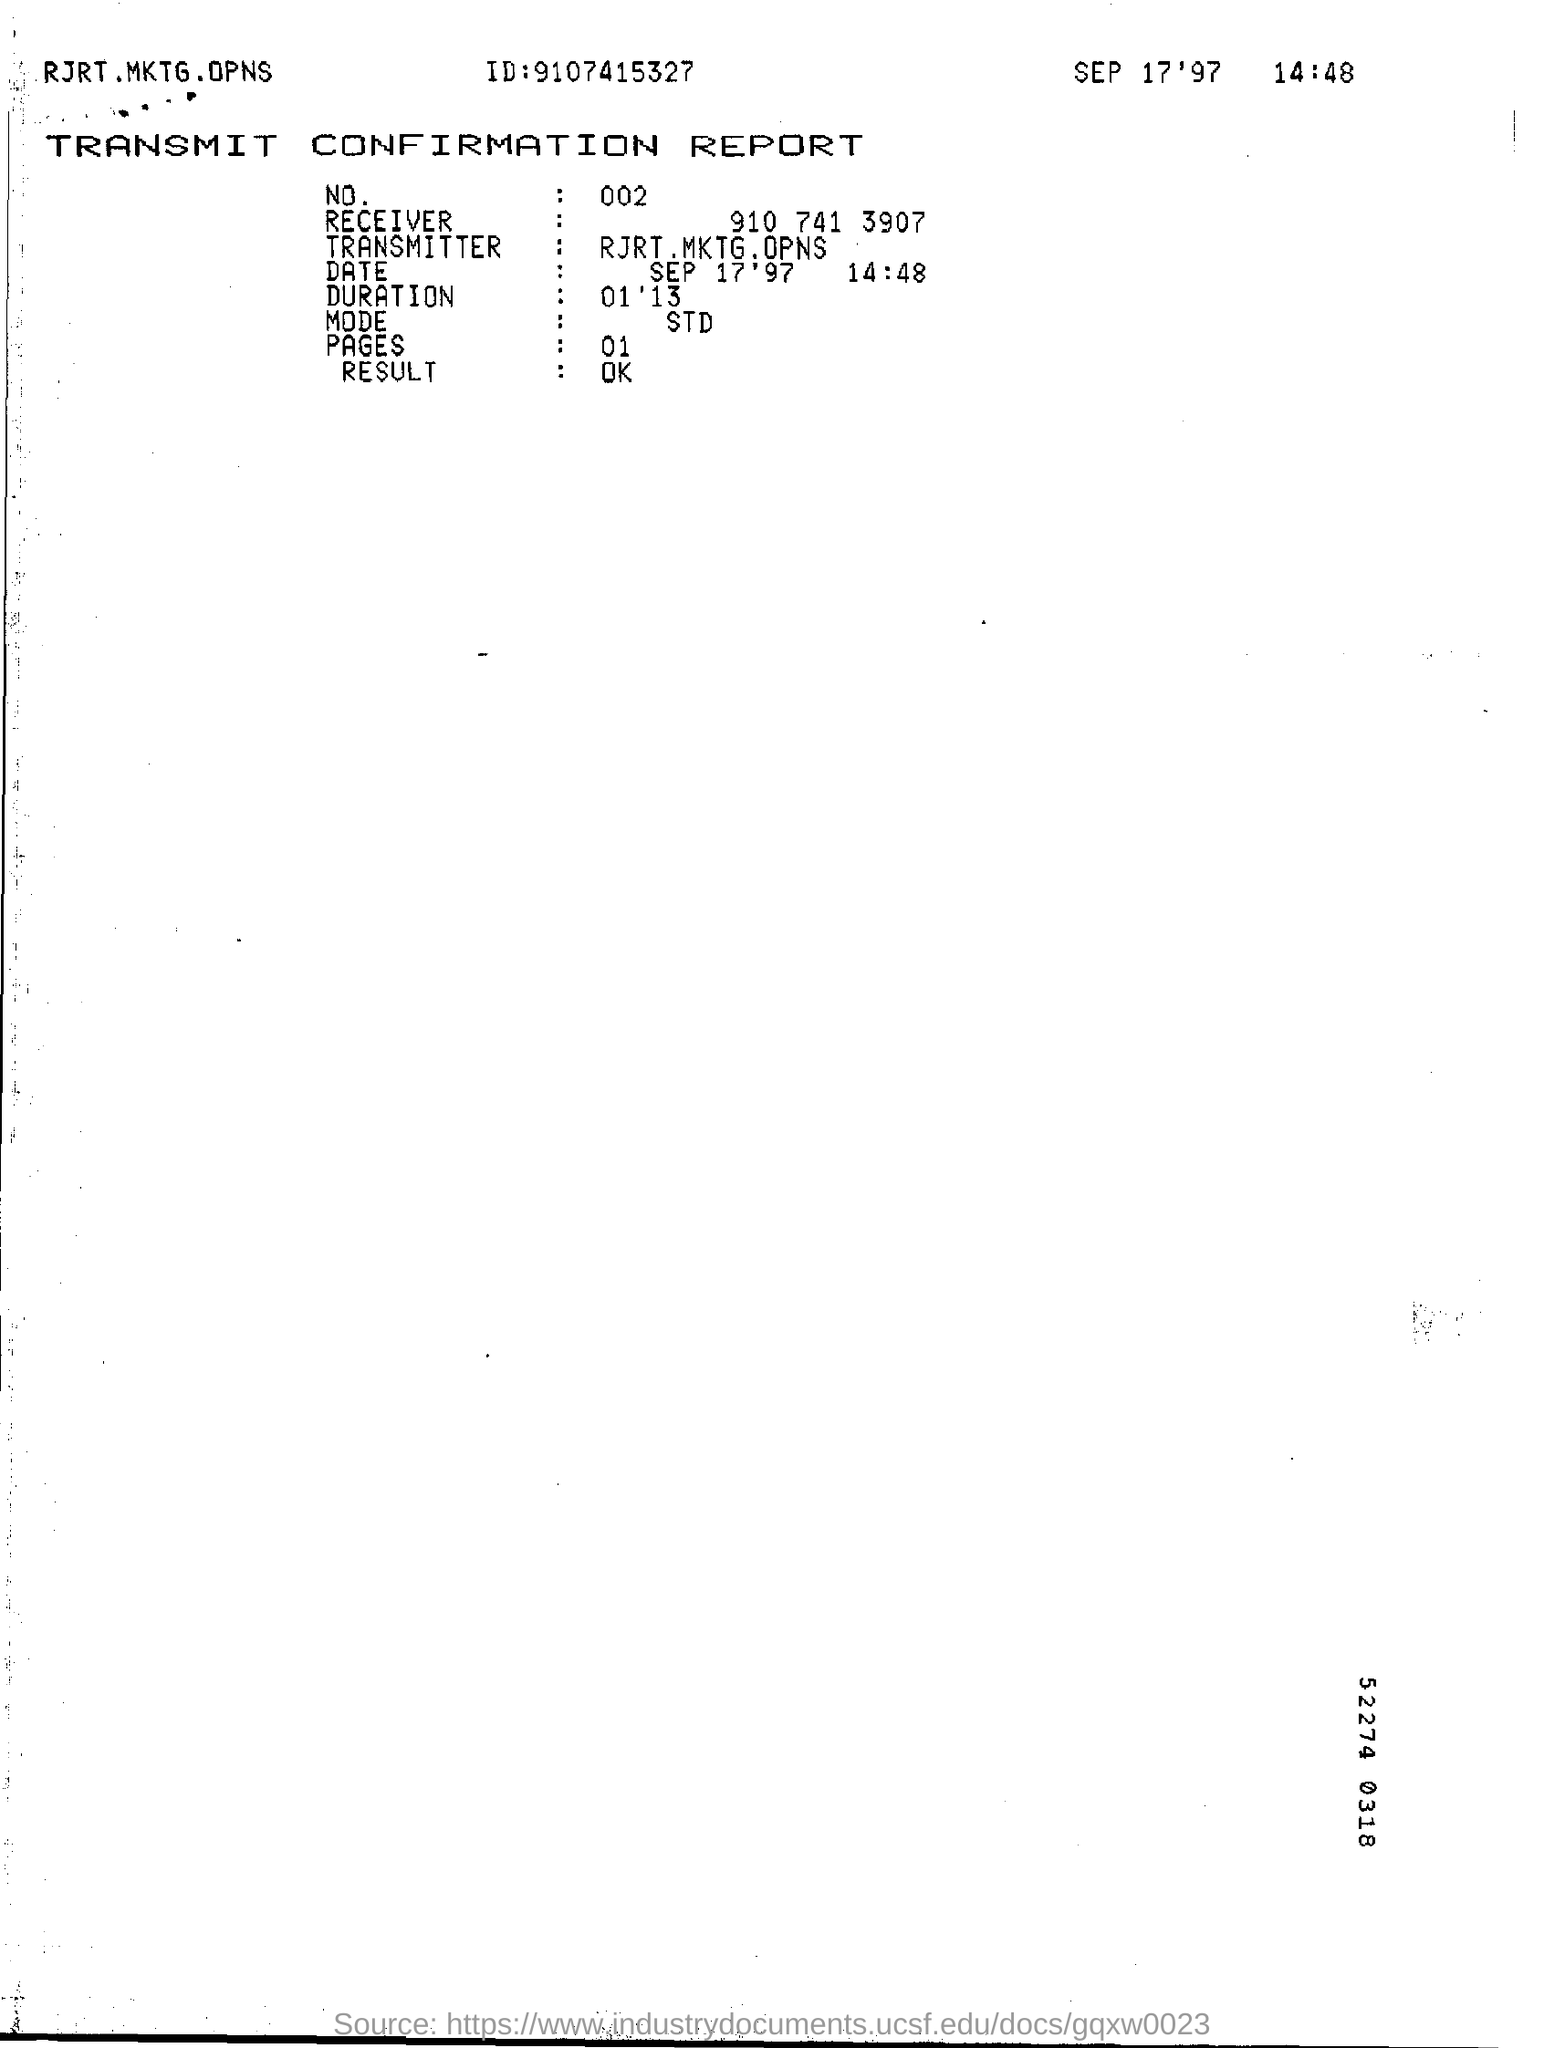Highlight a few significant elements in this photo. The date and time mentioned in the report is September 17, 1997 at 2:48 pm. The ID mentioned in the report is 9107415327... 